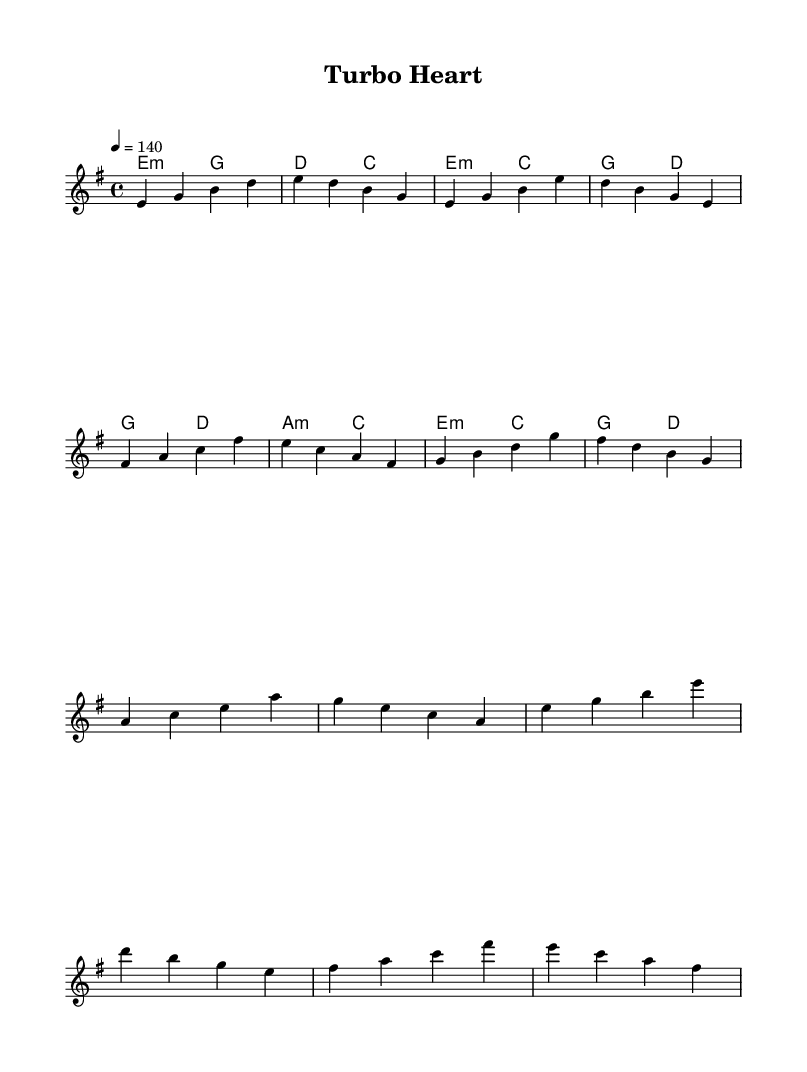What is the key signature of this music? The key signature is E minor, which contains one sharp (F#). E minor is indicated at the beginning of the sheet music.
Answer: E minor What is the time signature of this music? The time signature is 4/4, meaning there are four beats per measure, which is clearly noted at the beginning of the score.
Answer: 4/4 What is the tempo marking of this piece? The tempo is marked at 140 beats per minute, indicating that the piece should be played at a brisk pace. This is found in the tempo section of the score.
Answer: 140 What is the first chord of the piece? The first chord listed in the harmonies is E minor, which is represented as e2:m in the chord mode.
Answer: E minor How many measures are in the chorus section? The chorus section comprises four measures, as structured in the sheet music, which can be counted from the melody and harmonies.
Answer: 4 What musical style is this piece likely to represent? This piece likely represents K-Pop, characterized by its high energy and catchy beats typical of the genre, especially with its racing themes.
Answer: K-Pop Which dynamic level is typically associated with high-energy K-Pop songs? High-energy K-Pop tracks often feature loud dynamics to enhance excitement, although not explicitly stated, it can be inferred from the context of the structure.
Answer: Loud 